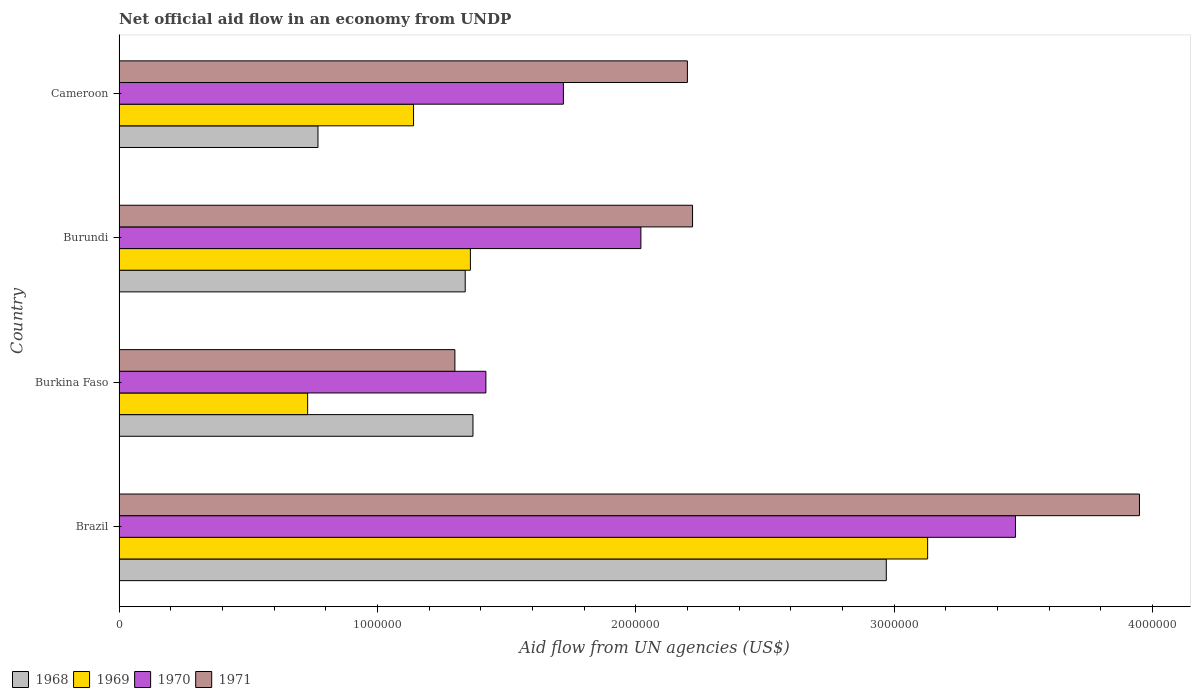How many groups of bars are there?
Make the answer very short. 4. Are the number of bars per tick equal to the number of legend labels?
Your response must be concise. Yes. How many bars are there on the 1st tick from the top?
Your response must be concise. 4. How many bars are there on the 4th tick from the bottom?
Provide a succinct answer. 4. What is the label of the 1st group of bars from the top?
Ensure brevity in your answer.  Cameroon. What is the net official aid flow in 1971 in Burundi?
Offer a terse response. 2.22e+06. Across all countries, what is the maximum net official aid flow in 1971?
Offer a very short reply. 3.95e+06. Across all countries, what is the minimum net official aid flow in 1969?
Your answer should be compact. 7.30e+05. In which country was the net official aid flow in 1969 maximum?
Your answer should be very brief. Brazil. In which country was the net official aid flow in 1968 minimum?
Make the answer very short. Cameroon. What is the total net official aid flow in 1968 in the graph?
Keep it short and to the point. 6.45e+06. What is the difference between the net official aid flow in 1970 in Brazil and that in Cameroon?
Give a very brief answer. 1.75e+06. What is the average net official aid flow in 1971 per country?
Offer a very short reply. 2.42e+06. What is the difference between the net official aid flow in 1968 and net official aid flow in 1971 in Brazil?
Your answer should be very brief. -9.80e+05. What is the ratio of the net official aid flow in 1970 in Burundi to that in Cameroon?
Keep it short and to the point. 1.17. Is the net official aid flow in 1971 in Brazil less than that in Cameroon?
Keep it short and to the point. No. Is the difference between the net official aid flow in 1968 in Burundi and Cameroon greater than the difference between the net official aid flow in 1971 in Burundi and Cameroon?
Your response must be concise. Yes. What is the difference between the highest and the second highest net official aid flow in 1969?
Your answer should be compact. 1.77e+06. What is the difference between the highest and the lowest net official aid flow in 1969?
Your answer should be compact. 2.40e+06. What does the 4th bar from the top in Brazil represents?
Provide a short and direct response. 1968. What does the 3rd bar from the bottom in Cameroon represents?
Your answer should be compact. 1970. What is the difference between two consecutive major ticks on the X-axis?
Offer a very short reply. 1.00e+06. Are the values on the major ticks of X-axis written in scientific E-notation?
Your response must be concise. No. Does the graph contain any zero values?
Ensure brevity in your answer.  No. How many legend labels are there?
Make the answer very short. 4. How are the legend labels stacked?
Keep it short and to the point. Horizontal. What is the title of the graph?
Give a very brief answer. Net official aid flow in an economy from UNDP. What is the label or title of the X-axis?
Keep it short and to the point. Aid flow from UN agencies (US$). What is the label or title of the Y-axis?
Make the answer very short. Country. What is the Aid flow from UN agencies (US$) of 1968 in Brazil?
Your answer should be compact. 2.97e+06. What is the Aid flow from UN agencies (US$) in 1969 in Brazil?
Provide a short and direct response. 3.13e+06. What is the Aid flow from UN agencies (US$) of 1970 in Brazil?
Ensure brevity in your answer.  3.47e+06. What is the Aid flow from UN agencies (US$) of 1971 in Brazil?
Offer a very short reply. 3.95e+06. What is the Aid flow from UN agencies (US$) of 1968 in Burkina Faso?
Provide a succinct answer. 1.37e+06. What is the Aid flow from UN agencies (US$) of 1969 in Burkina Faso?
Keep it short and to the point. 7.30e+05. What is the Aid flow from UN agencies (US$) of 1970 in Burkina Faso?
Your response must be concise. 1.42e+06. What is the Aid flow from UN agencies (US$) of 1971 in Burkina Faso?
Provide a short and direct response. 1.30e+06. What is the Aid flow from UN agencies (US$) in 1968 in Burundi?
Provide a short and direct response. 1.34e+06. What is the Aid flow from UN agencies (US$) of 1969 in Burundi?
Offer a terse response. 1.36e+06. What is the Aid flow from UN agencies (US$) in 1970 in Burundi?
Offer a very short reply. 2.02e+06. What is the Aid flow from UN agencies (US$) of 1971 in Burundi?
Ensure brevity in your answer.  2.22e+06. What is the Aid flow from UN agencies (US$) of 1968 in Cameroon?
Provide a short and direct response. 7.70e+05. What is the Aid flow from UN agencies (US$) of 1969 in Cameroon?
Offer a very short reply. 1.14e+06. What is the Aid flow from UN agencies (US$) in 1970 in Cameroon?
Offer a terse response. 1.72e+06. What is the Aid flow from UN agencies (US$) of 1971 in Cameroon?
Provide a short and direct response. 2.20e+06. Across all countries, what is the maximum Aid flow from UN agencies (US$) of 1968?
Your answer should be compact. 2.97e+06. Across all countries, what is the maximum Aid flow from UN agencies (US$) in 1969?
Give a very brief answer. 3.13e+06. Across all countries, what is the maximum Aid flow from UN agencies (US$) in 1970?
Your answer should be compact. 3.47e+06. Across all countries, what is the maximum Aid flow from UN agencies (US$) of 1971?
Offer a terse response. 3.95e+06. Across all countries, what is the minimum Aid flow from UN agencies (US$) of 1968?
Keep it short and to the point. 7.70e+05. Across all countries, what is the minimum Aid flow from UN agencies (US$) of 1969?
Your answer should be compact. 7.30e+05. Across all countries, what is the minimum Aid flow from UN agencies (US$) of 1970?
Provide a short and direct response. 1.42e+06. Across all countries, what is the minimum Aid flow from UN agencies (US$) in 1971?
Offer a terse response. 1.30e+06. What is the total Aid flow from UN agencies (US$) of 1968 in the graph?
Provide a short and direct response. 6.45e+06. What is the total Aid flow from UN agencies (US$) of 1969 in the graph?
Keep it short and to the point. 6.36e+06. What is the total Aid flow from UN agencies (US$) of 1970 in the graph?
Offer a terse response. 8.63e+06. What is the total Aid flow from UN agencies (US$) of 1971 in the graph?
Provide a succinct answer. 9.67e+06. What is the difference between the Aid flow from UN agencies (US$) of 1968 in Brazil and that in Burkina Faso?
Offer a terse response. 1.60e+06. What is the difference between the Aid flow from UN agencies (US$) of 1969 in Brazil and that in Burkina Faso?
Your answer should be very brief. 2.40e+06. What is the difference between the Aid flow from UN agencies (US$) of 1970 in Brazil and that in Burkina Faso?
Your answer should be very brief. 2.05e+06. What is the difference between the Aid flow from UN agencies (US$) of 1971 in Brazil and that in Burkina Faso?
Offer a very short reply. 2.65e+06. What is the difference between the Aid flow from UN agencies (US$) in 1968 in Brazil and that in Burundi?
Give a very brief answer. 1.63e+06. What is the difference between the Aid flow from UN agencies (US$) in 1969 in Brazil and that in Burundi?
Provide a succinct answer. 1.77e+06. What is the difference between the Aid flow from UN agencies (US$) of 1970 in Brazil and that in Burundi?
Give a very brief answer. 1.45e+06. What is the difference between the Aid flow from UN agencies (US$) of 1971 in Brazil and that in Burundi?
Ensure brevity in your answer.  1.73e+06. What is the difference between the Aid flow from UN agencies (US$) in 1968 in Brazil and that in Cameroon?
Your response must be concise. 2.20e+06. What is the difference between the Aid flow from UN agencies (US$) of 1969 in Brazil and that in Cameroon?
Your answer should be compact. 1.99e+06. What is the difference between the Aid flow from UN agencies (US$) in 1970 in Brazil and that in Cameroon?
Keep it short and to the point. 1.75e+06. What is the difference between the Aid flow from UN agencies (US$) in 1971 in Brazil and that in Cameroon?
Your response must be concise. 1.75e+06. What is the difference between the Aid flow from UN agencies (US$) in 1969 in Burkina Faso and that in Burundi?
Ensure brevity in your answer.  -6.30e+05. What is the difference between the Aid flow from UN agencies (US$) in 1970 in Burkina Faso and that in Burundi?
Your answer should be very brief. -6.00e+05. What is the difference between the Aid flow from UN agencies (US$) in 1971 in Burkina Faso and that in Burundi?
Provide a short and direct response. -9.20e+05. What is the difference between the Aid flow from UN agencies (US$) in 1969 in Burkina Faso and that in Cameroon?
Offer a very short reply. -4.10e+05. What is the difference between the Aid flow from UN agencies (US$) of 1971 in Burkina Faso and that in Cameroon?
Offer a terse response. -9.00e+05. What is the difference between the Aid flow from UN agencies (US$) of 1968 in Burundi and that in Cameroon?
Offer a very short reply. 5.70e+05. What is the difference between the Aid flow from UN agencies (US$) of 1971 in Burundi and that in Cameroon?
Your response must be concise. 2.00e+04. What is the difference between the Aid flow from UN agencies (US$) of 1968 in Brazil and the Aid flow from UN agencies (US$) of 1969 in Burkina Faso?
Give a very brief answer. 2.24e+06. What is the difference between the Aid flow from UN agencies (US$) of 1968 in Brazil and the Aid flow from UN agencies (US$) of 1970 in Burkina Faso?
Ensure brevity in your answer.  1.55e+06. What is the difference between the Aid flow from UN agencies (US$) in 1968 in Brazil and the Aid flow from UN agencies (US$) in 1971 in Burkina Faso?
Your answer should be compact. 1.67e+06. What is the difference between the Aid flow from UN agencies (US$) in 1969 in Brazil and the Aid flow from UN agencies (US$) in 1970 in Burkina Faso?
Your answer should be compact. 1.71e+06. What is the difference between the Aid flow from UN agencies (US$) in 1969 in Brazil and the Aid flow from UN agencies (US$) in 1971 in Burkina Faso?
Your answer should be compact. 1.83e+06. What is the difference between the Aid flow from UN agencies (US$) of 1970 in Brazil and the Aid flow from UN agencies (US$) of 1971 in Burkina Faso?
Your answer should be compact. 2.17e+06. What is the difference between the Aid flow from UN agencies (US$) of 1968 in Brazil and the Aid flow from UN agencies (US$) of 1969 in Burundi?
Keep it short and to the point. 1.61e+06. What is the difference between the Aid flow from UN agencies (US$) in 1968 in Brazil and the Aid flow from UN agencies (US$) in 1970 in Burundi?
Your answer should be very brief. 9.50e+05. What is the difference between the Aid flow from UN agencies (US$) in 1968 in Brazil and the Aid flow from UN agencies (US$) in 1971 in Burundi?
Provide a short and direct response. 7.50e+05. What is the difference between the Aid flow from UN agencies (US$) of 1969 in Brazil and the Aid flow from UN agencies (US$) of 1970 in Burundi?
Offer a terse response. 1.11e+06. What is the difference between the Aid flow from UN agencies (US$) in 1969 in Brazil and the Aid flow from UN agencies (US$) in 1971 in Burundi?
Your response must be concise. 9.10e+05. What is the difference between the Aid flow from UN agencies (US$) in 1970 in Brazil and the Aid flow from UN agencies (US$) in 1971 in Burundi?
Give a very brief answer. 1.25e+06. What is the difference between the Aid flow from UN agencies (US$) of 1968 in Brazil and the Aid flow from UN agencies (US$) of 1969 in Cameroon?
Keep it short and to the point. 1.83e+06. What is the difference between the Aid flow from UN agencies (US$) in 1968 in Brazil and the Aid flow from UN agencies (US$) in 1970 in Cameroon?
Provide a short and direct response. 1.25e+06. What is the difference between the Aid flow from UN agencies (US$) in 1968 in Brazil and the Aid flow from UN agencies (US$) in 1971 in Cameroon?
Offer a terse response. 7.70e+05. What is the difference between the Aid flow from UN agencies (US$) of 1969 in Brazil and the Aid flow from UN agencies (US$) of 1970 in Cameroon?
Provide a short and direct response. 1.41e+06. What is the difference between the Aid flow from UN agencies (US$) of 1969 in Brazil and the Aid flow from UN agencies (US$) of 1971 in Cameroon?
Keep it short and to the point. 9.30e+05. What is the difference between the Aid flow from UN agencies (US$) in 1970 in Brazil and the Aid flow from UN agencies (US$) in 1971 in Cameroon?
Offer a very short reply. 1.27e+06. What is the difference between the Aid flow from UN agencies (US$) of 1968 in Burkina Faso and the Aid flow from UN agencies (US$) of 1969 in Burundi?
Offer a terse response. 10000. What is the difference between the Aid flow from UN agencies (US$) of 1968 in Burkina Faso and the Aid flow from UN agencies (US$) of 1970 in Burundi?
Offer a terse response. -6.50e+05. What is the difference between the Aid flow from UN agencies (US$) of 1968 in Burkina Faso and the Aid flow from UN agencies (US$) of 1971 in Burundi?
Provide a succinct answer. -8.50e+05. What is the difference between the Aid flow from UN agencies (US$) in 1969 in Burkina Faso and the Aid flow from UN agencies (US$) in 1970 in Burundi?
Your response must be concise. -1.29e+06. What is the difference between the Aid flow from UN agencies (US$) in 1969 in Burkina Faso and the Aid flow from UN agencies (US$) in 1971 in Burundi?
Your response must be concise. -1.49e+06. What is the difference between the Aid flow from UN agencies (US$) of 1970 in Burkina Faso and the Aid flow from UN agencies (US$) of 1971 in Burundi?
Your answer should be very brief. -8.00e+05. What is the difference between the Aid flow from UN agencies (US$) in 1968 in Burkina Faso and the Aid flow from UN agencies (US$) in 1970 in Cameroon?
Your answer should be very brief. -3.50e+05. What is the difference between the Aid flow from UN agencies (US$) in 1968 in Burkina Faso and the Aid flow from UN agencies (US$) in 1971 in Cameroon?
Provide a succinct answer. -8.30e+05. What is the difference between the Aid flow from UN agencies (US$) of 1969 in Burkina Faso and the Aid flow from UN agencies (US$) of 1970 in Cameroon?
Ensure brevity in your answer.  -9.90e+05. What is the difference between the Aid flow from UN agencies (US$) in 1969 in Burkina Faso and the Aid flow from UN agencies (US$) in 1971 in Cameroon?
Your response must be concise. -1.47e+06. What is the difference between the Aid flow from UN agencies (US$) in 1970 in Burkina Faso and the Aid flow from UN agencies (US$) in 1971 in Cameroon?
Make the answer very short. -7.80e+05. What is the difference between the Aid flow from UN agencies (US$) in 1968 in Burundi and the Aid flow from UN agencies (US$) in 1969 in Cameroon?
Offer a terse response. 2.00e+05. What is the difference between the Aid flow from UN agencies (US$) in 1968 in Burundi and the Aid flow from UN agencies (US$) in 1970 in Cameroon?
Offer a very short reply. -3.80e+05. What is the difference between the Aid flow from UN agencies (US$) of 1968 in Burundi and the Aid flow from UN agencies (US$) of 1971 in Cameroon?
Provide a succinct answer. -8.60e+05. What is the difference between the Aid flow from UN agencies (US$) of 1969 in Burundi and the Aid flow from UN agencies (US$) of 1970 in Cameroon?
Provide a short and direct response. -3.60e+05. What is the difference between the Aid flow from UN agencies (US$) of 1969 in Burundi and the Aid flow from UN agencies (US$) of 1971 in Cameroon?
Offer a very short reply. -8.40e+05. What is the average Aid flow from UN agencies (US$) in 1968 per country?
Provide a succinct answer. 1.61e+06. What is the average Aid flow from UN agencies (US$) in 1969 per country?
Provide a short and direct response. 1.59e+06. What is the average Aid flow from UN agencies (US$) of 1970 per country?
Offer a very short reply. 2.16e+06. What is the average Aid flow from UN agencies (US$) in 1971 per country?
Your answer should be compact. 2.42e+06. What is the difference between the Aid flow from UN agencies (US$) of 1968 and Aid flow from UN agencies (US$) of 1969 in Brazil?
Offer a very short reply. -1.60e+05. What is the difference between the Aid flow from UN agencies (US$) in 1968 and Aid flow from UN agencies (US$) in 1970 in Brazil?
Your answer should be very brief. -5.00e+05. What is the difference between the Aid flow from UN agencies (US$) in 1968 and Aid flow from UN agencies (US$) in 1971 in Brazil?
Ensure brevity in your answer.  -9.80e+05. What is the difference between the Aid flow from UN agencies (US$) of 1969 and Aid flow from UN agencies (US$) of 1971 in Brazil?
Give a very brief answer. -8.20e+05. What is the difference between the Aid flow from UN agencies (US$) of 1970 and Aid flow from UN agencies (US$) of 1971 in Brazil?
Offer a very short reply. -4.80e+05. What is the difference between the Aid flow from UN agencies (US$) in 1968 and Aid flow from UN agencies (US$) in 1969 in Burkina Faso?
Ensure brevity in your answer.  6.40e+05. What is the difference between the Aid flow from UN agencies (US$) in 1968 and Aid flow from UN agencies (US$) in 1970 in Burkina Faso?
Keep it short and to the point. -5.00e+04. What is the difference between the Aid flow from UN agencies (US$) of 1968 and Aid flow from UN agencies (US$) of 1971 in Burkina Faso?
Your answer should be very brief. 7.00e+04. What is the difference between the Aid flow from UN agencies (US$) in 1969 and Aid flow from UN agencies (US$) in 1970 in Burkina Faso?
Provide a succinct answer. -6.90e+05. What is the difference between the Aid flow from UN agencies (US$) in 1969 and Aid flow from UN agencies (US$) in 1971 in Burkina Faso?
Make the answer very short. -5.70e+05. What is the difference between the Aid flow from UN agencies (US$) of 1970 and Aid flow from UN agencies (US$) of 1971 in Burkina Faso?
Offer a very short reply. 1.20e+05. What is the difference between the Aid flow from UN agencies (US$) in 1968 and Aid flow from UN agencies (US$) in 1970 in Burundi?
Give a very brief answer. -6.80e+05. What is the difference between the Aid flow from UN agencies (US$) in 1968 and Aid flow from UN agencies (US$) in 1971 in Burundi?
Ensure brevity in your answer.  -8.80e+05. What is the difference between the Aid flow from UN agencies (US$) of 1969 and Aid flow from UN agencies (US$) of 1970 in Burundi?
Make the answer very short. -6.60e+05. What is the difference between the Aid flow from UN agencies (US$) of 1969 and Aid flow from UN agencies (US$) of 1971 in Burundi?
Offer a terse response. -8.60e+05. What is the difference between the Aid flow from UN agencies (US$) in 1968 and Aid flow from UN agencies (US$) in 1969 in Cameroon?
Provide a short and direct response. -3.70e+05. What is the difference between the Aid flow from UN agencies (US$) of 1968 and Aid flow from UN agencies (US$) of 1970 in Cameroon?
Provide a short and direct response. -9.50e+05. What is the difference between the Aid flow from UN agencies (US$) in 1968 and Aid flow from UN agencies (US$) in 1971 in Cameroon?
Your answer should be compact. -1.43e+06. What is the difference between the Aid flow from UN agencies (US$) in 1969 and Aid flow from UN agencies (US$) in 1970 in Cameroon?
Your answer should be compact. -5.80e+05. What is the difference between the Aid flow from UN agencies (US$) of 1969 and Aid flow from UN agencies (US$) of 1971 in Cameroon?
Your response must be concise. -1.06e+06. What is the difference between the Aid flow from UN agencies (US$) of 1970 and Aid flow from UN agencies (US$) of 1971 in Cameroon?
Provide a succinct answer. -4.80e+05. What is the ratio of the Aid flow from UN agencies (US$) of 1968 in Brazil to that in Burkina Faso?
Keep it short and to the point. 2.17. What is the ratio of the Aid flow from UN agencies (US$) in 1969 in Brazil to that in Burkina Faso?
Make the answer very short. 4.29. What is the ratio of the Aid flow from UN agencies (US$) of 1970 in Brazil to that in Burkina Faso?
Your answer should be very brief. 2.44. What is the ratio of the Aid flow from UN agencies (US$) in 1971 in Brazil to that in Burkina Faso?
Offer a terse response. 3.04. What is the ratio of the Aid flow from UN agencies (US$) of 1968 in Brazil to that in Burundi?
Offer a very short reply. 2.22. What is the ratio of the Aid flow from UN agencies (US$) in 1969 in Brazil to that in Burundi?
Ensure brevity in your answer.  2.3. What is the ratio of the Aid flow from UN agencies (US$) of 1970 in Brazil to that in Burundi?
Provide a succinct answer. 1.72. What is the ratio of the Aid flow from UN agencies (US$) of 1971 in Brazil to that in Burundi?
Offer a terse response. 1.78. What is the ratio of the Aid flow from UN agencies (US$) in 1968 in Brazil to that in Cameroon?
Provide a short and direct response. 3.86. What is the ratio of the Aid flow from UN agencies (US$) of 1969 in Brazil to that in Cameroon?
Provide a short and direct response. 2.75. What is the ratio of the Aid flow from UN agencies (US$) in 1970 in Brazil to that in Cameroon?
Your answer should be very brief. 2.02. What is the ratio of the Aid flow from UN agencies (US$) of 1971 in Brazil to that in Cameroon?
Make the answer very short. 1.8. What is the ratio of the Aid flow from UN agencies (US$) of 1968 in Burkina Faso to that in Burundi?
Offer a terse response. 1.02. What is the ratio of the Aid flow from UN agencies (US$) of 1969 in Burkina Faso to that in Burundi?
Your answer should be very brief. 0.54. What is the ratio of the Aid flow from UN agencies (US$) in 1970 in Burkina Faso to that in Burundi?
Your answer should be compact. 0.7. What is the ratio of the Aid flow from UN agencies (US$) in 1971 in Burkina Faso to that in Burundi?
Keep it short and to the point. 0.59. What is the ratio of the Aid flow from UN agencies (US$) of 1968 in Burkina Faso to that in Cameroon?
Your answer should be compact. 1.78. What is the ratio of the Aid flow from UN agencies (US$) in 1969 in Burkina Faso to that in Cameroon?
Ensure brevity in your answer.  0.64. What is the ratio of the Aid flow from UN agencies (US$) of 1970 in Burkina Faso to that in Cameroon?
Your answer should be very brief. 0.83. What is the ratio of the Aid flow from UN agencies (US$) of 1971 in Burkina Faso to that in Cameroon?
Your answer should be compact. 0.59. What is the ratio of the Aid flow from UN agencies (US$) of 1968 in Burundi to that in Cameroon?
Provide a succinct answer. 1.74. What is the ratio of the Aid flow from UN agencies (US$) in 1969 in Burundi to that in Cameroon?
Provide a short and direct response. 1.19. What is the ratio of the Aid flow from UN agencies (US$) in 1970 in Burundi to that in Cameroon?
Offer a terse response. 1.17. What is the ratio of the Aid flow from UN agencies (US$) of 1971 in Burundi to that in Cameroon?
Offer a very short reply. 1.01. What is the difference between the highest and the second highest Aid flow from UN agencies (US$) in 1968?
Your response must be concise. 1.60e+06. What is the difference between the highest and the second highest Aid flow from UN agencies (US$) of 1969?
Your answer should be compact. 1.77e+06. What is the difference between the highest and the second highest Aid flow from UN agencies (US$) of 1970?
Give a very brief answer. 1.45e+06. What is the difference between the highest and the second highest Aid flow from UN agencies (US$) of 1971?
Keep it short and to the point. 1.73e+06. What is the difference between the highest and the lowest Aid flow from UN agencies (US$) in 1968?
Make the answer very short. 2.20e+06. What is the difference between the highest and the lowest Aid flow from UN agencies (US$) in 1969?
Give a very brief answer. 2.40e+06. What is the difference between the highest and the lowest Aid flow from UN agencies (US$) in 1970?
Keep it short and to the point. 2.05e+06. What is the difference between the highest and the lowest Aid flow from UN agencies (US$) of 1971?
Your answer should be compact. 2.65e+06. 